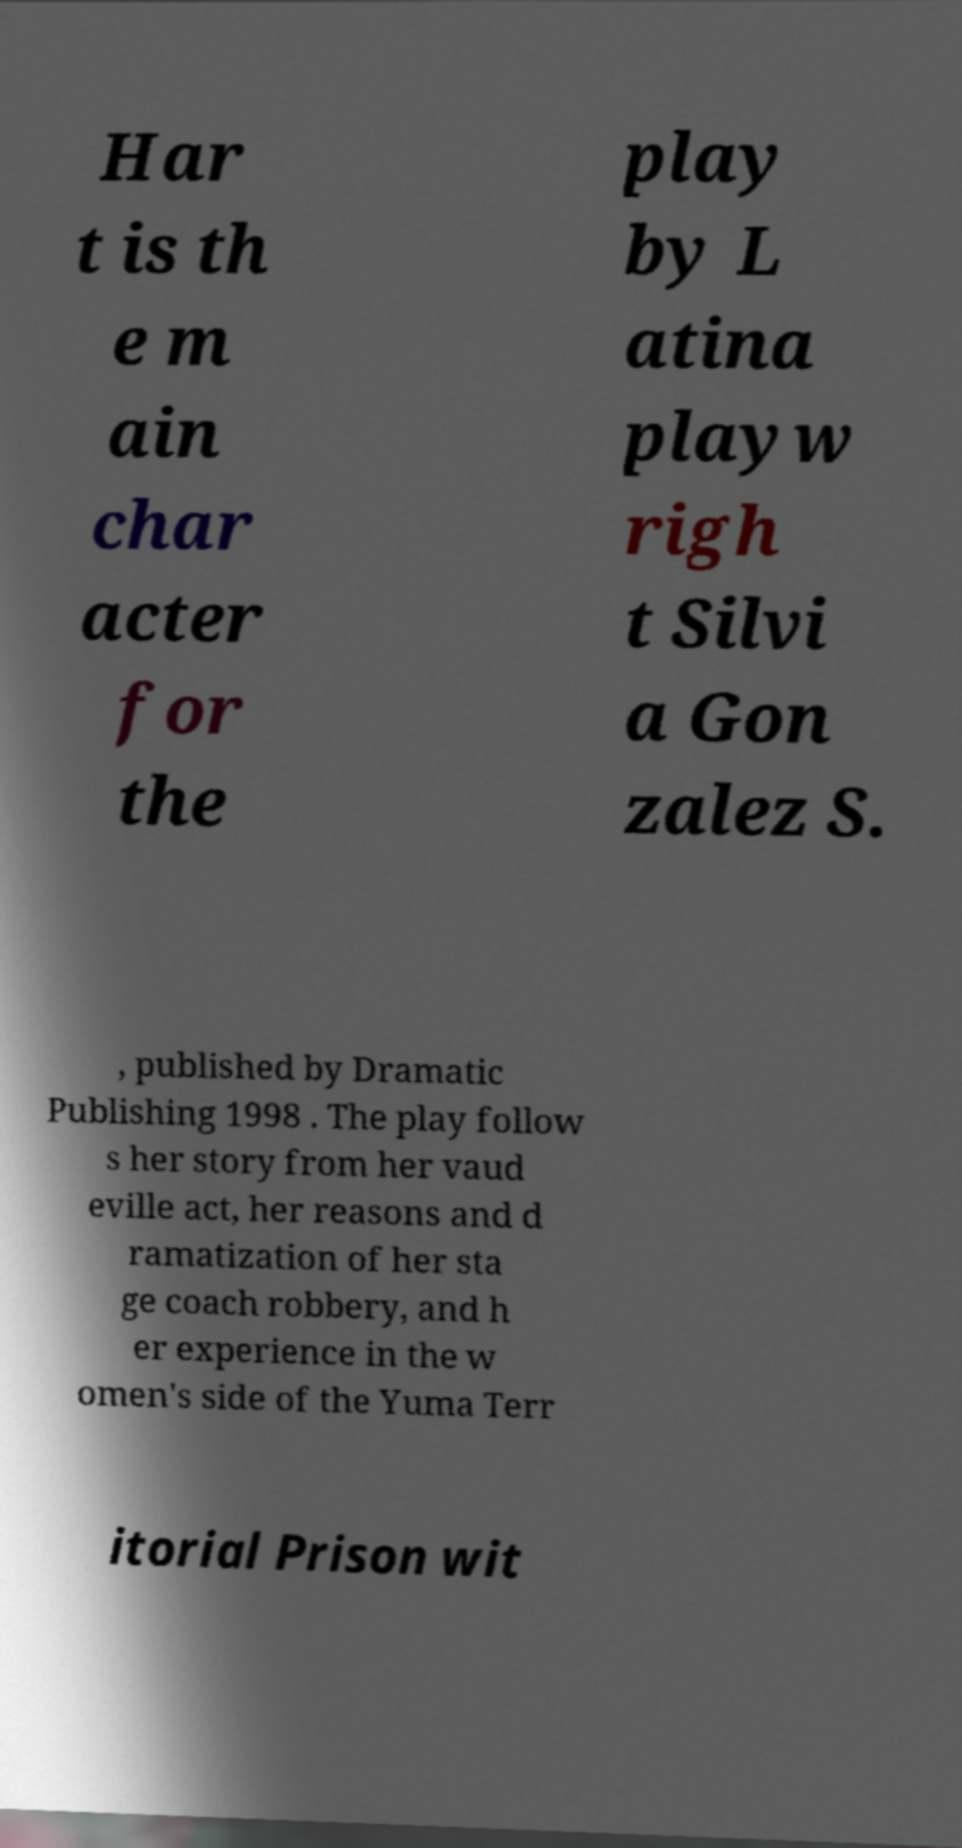I need the written content from this picture converted into text. Can you do that? Har t is th e m ain char acter for the play by L atina playw righ t Silvi a Gon zalez S. , published by Dramatic Publishing 1998 . The play follow s her story from her vaud eville act, her reasons and d ramatization of her sta ge coach robbery, and h er experience in the w omen's side of the Yuma Terr itorial Prison wit 